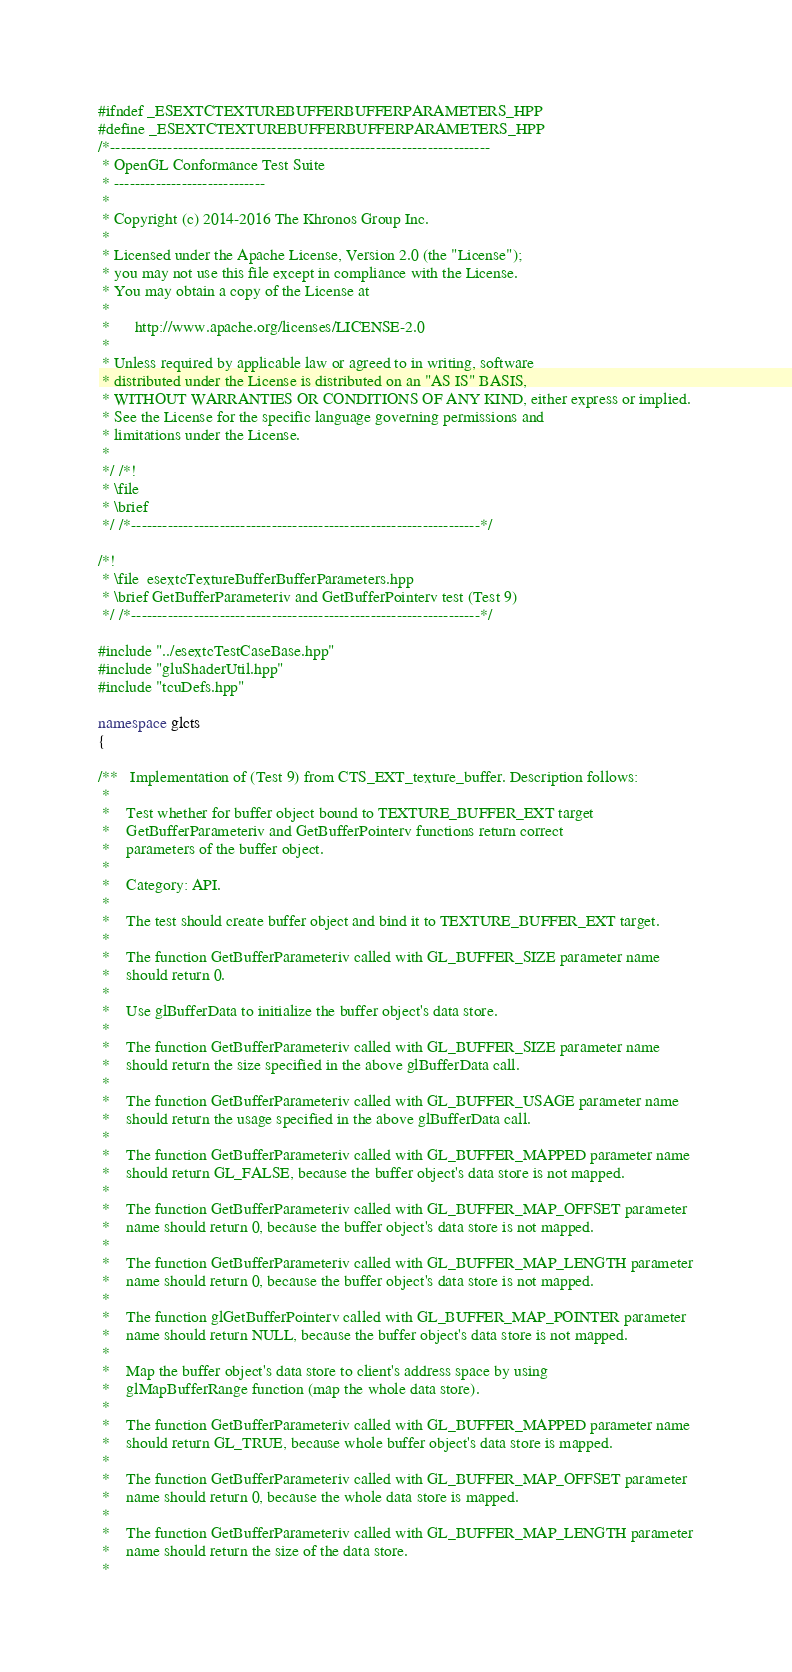<code> <loc_0><loc_0><loc_500><loc_500><_C++_>#ifndef _ESEXTCTEXTUREBUFFERBUFFERPARAMETERS_HPP
#define _ESEXTCTEXTUREBUFFERBUFFERPARAMETERS_HPP
/*-------------------------------------------------------------------------
 * OpenGL Conformance Test Suite
 * -----------------------------
 *
 * Copyright (c) 2014-2016 The Khronos Group Inc.
 *
 * Licensed under the Apache License, Version 2.0 (the "License");
 * you may not use this file except in compliance with the License.
 * You may obtain a copy of the License at
 *
 *      http://www.apache.org/licenses/LICENSE-2.0
 *
 * Unless required by applicable law or agreed to in writing, software
 * distributed under the License is distributed on an "AS IS" BASIS,
 * WITHOUT WARRANTIES OR CONDITIONS OF ANY KIND, either express or implied.
 * See the License for the specific language governing permissions and
 * limitations under the License.
 *
 */ /*!
 * \file
 * \brief
 */ /*-------------------------------------------------------------------*/

/*!
 * \file  esextcTextureBufferBufferParameters.hpp
 * \brief GetBufferParameteriv and GetBufferPointerv test (Test 9)
 */ /*-------------------------------------------------------------------*/

#include "../esextcTestCaseBase.hpp"
#include "gluShaderUtil.hpp"
#include "tcuDefs.hpp"

namespace glcts
{

/**   Implementation of (Test 9) from CTS_EXT_texture_buffer. Description follows:
 *
 *    Test whether for buffer object bound to TEXTURE_BUFFER_EXT target
 *    GetBufferParameteriv and GetBufferPointerv functions return correct
 *    parameters of the buffer object.
 *
 *    Category: API.
 *
 *    The test should create buffer object and bind it to TEXTURE_BUFFER_EXT target.
 *
 *    The function GetBufferParameteriv called with GL_BUFFER_SIZE parameter name
 *    should return 0.
 *
 *    Use glBufferData to initialize the buffer object's data store.
 *
 *    The function GetBufferParameteriv called with GL_BUFFER_SIZE parameter name
 *    should return the size specified in the above glBufferData call.
 *
 *    The function GetBufferParameteriv called with GL_BUFFER_USAGE parameter name
 *    should return the usage specified in the above glBufferData call.
 *
 *    The function GetBufferParameteriv called with GL_BUFFER_MAPPED parameter name
 *    should return GL_FALSE, because the buffer object's data store is not mapped.
 *
 *    The function GetBufferParameteriv called with GL_BUFFER_MAP_OFFSET parameter
 *    name should return 0, because the buffer object's data store is not mapped.
 *
 *    The function GetBufferParameteriv called with GL_BUFFER_MAP_LENGTH parameter
 *    name should return 0, because the buffer object's data store is not mapped.
 *
 *    The function glGetBufferPointerv called with GL_BUFFER_MAP_POINTER parameter
 *    name should return NULL, because the buffer object's data store is not mapped.
 *
 *    Map the buffer object's data store to client's address space by using
 *    glMapBufferRange function (map the whole data store).
 *
 *    The function GetBufferParameteriv called with GL_BUFFER_MAPPED parameter name
 *    should return GL_TRUE, because whole buffer object's data store is mapped.
 *
 *    The function GetBufferParameteriv called with GL_BUFFER_MAP_OFFSET parameter
 *    name should return 0, because the whole data store is mapped.
 *
 *    The function GetBufferParameteriv called with GL_BUFFER_MAP_LENGTH parameter
 *    name should return the size of the data store.
 *</code> 